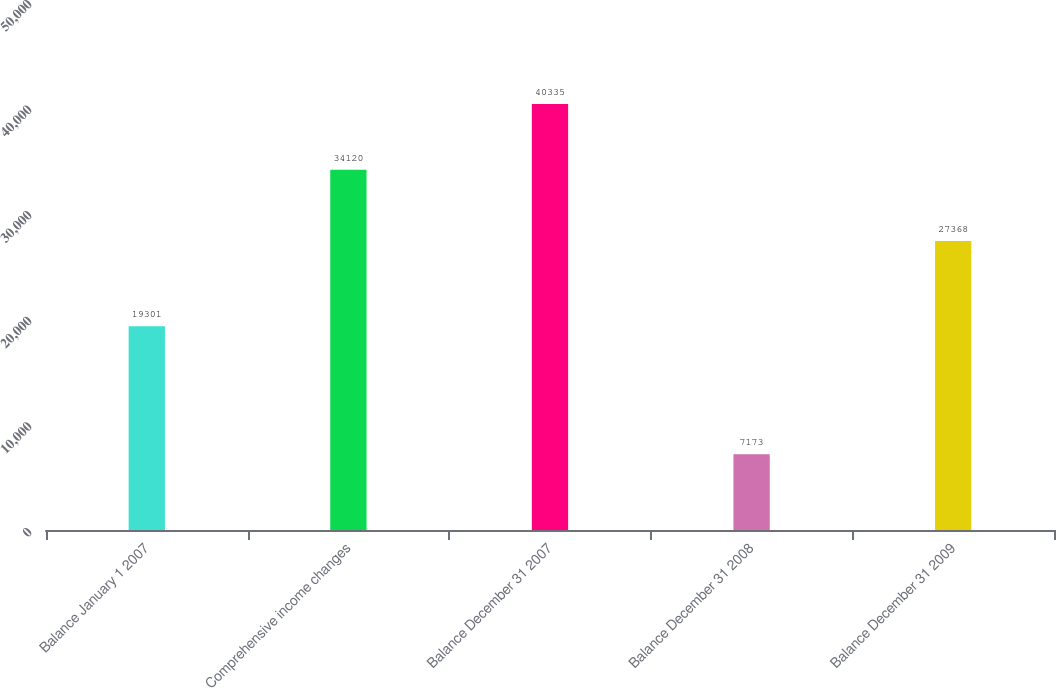<chart> <loc_0><loc_0><loc_500><loc_500><bar_chart><fcel>Balance January 1 2007<fcel>Comprehensive income changes<fcel>Balance December 31 2007<fcel>Balance December 31 2008<fcel>Balance December 31 2009<nl><fcel>19301<fcel>34120<fcel>40335<fcel>7173<fcel>27368<nl></chart> 